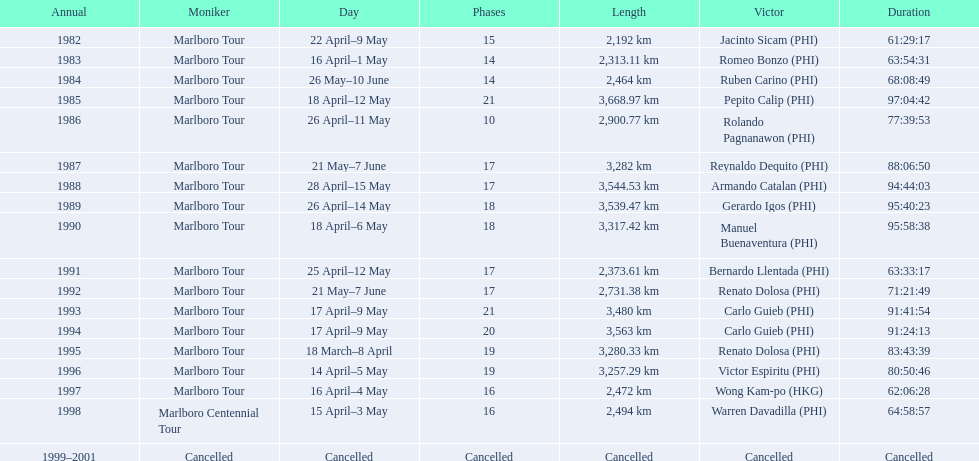How many parts were in the 1982 marlboro tour? 15. 